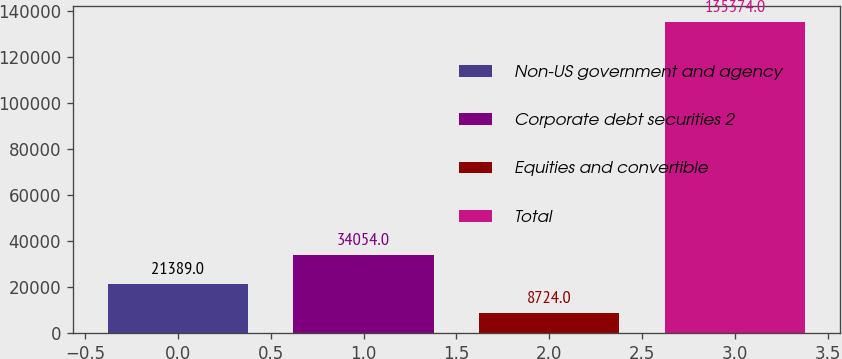Convert chart to OTSL. <chart><loc_0><loc_0><loc_500><loc_500><bar_chart><fcel>Non-US government and agency<fcel>Corporate debt securities 2<fcel>Equities and convertible<fcel>Total<nl><fcel>21389<fcel>34054<fcel>8724<fcel>135374<nl></chart> 